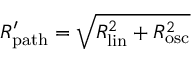Convert formula to latex. <formula><loc_0><loc_0><loc_500><loc_500>R _ { p a t h } ^ { \prime } = \sqrt { R _ { l i n } ^ { 2 } + R _ { o s c } ^ { 2 } }</formula> 